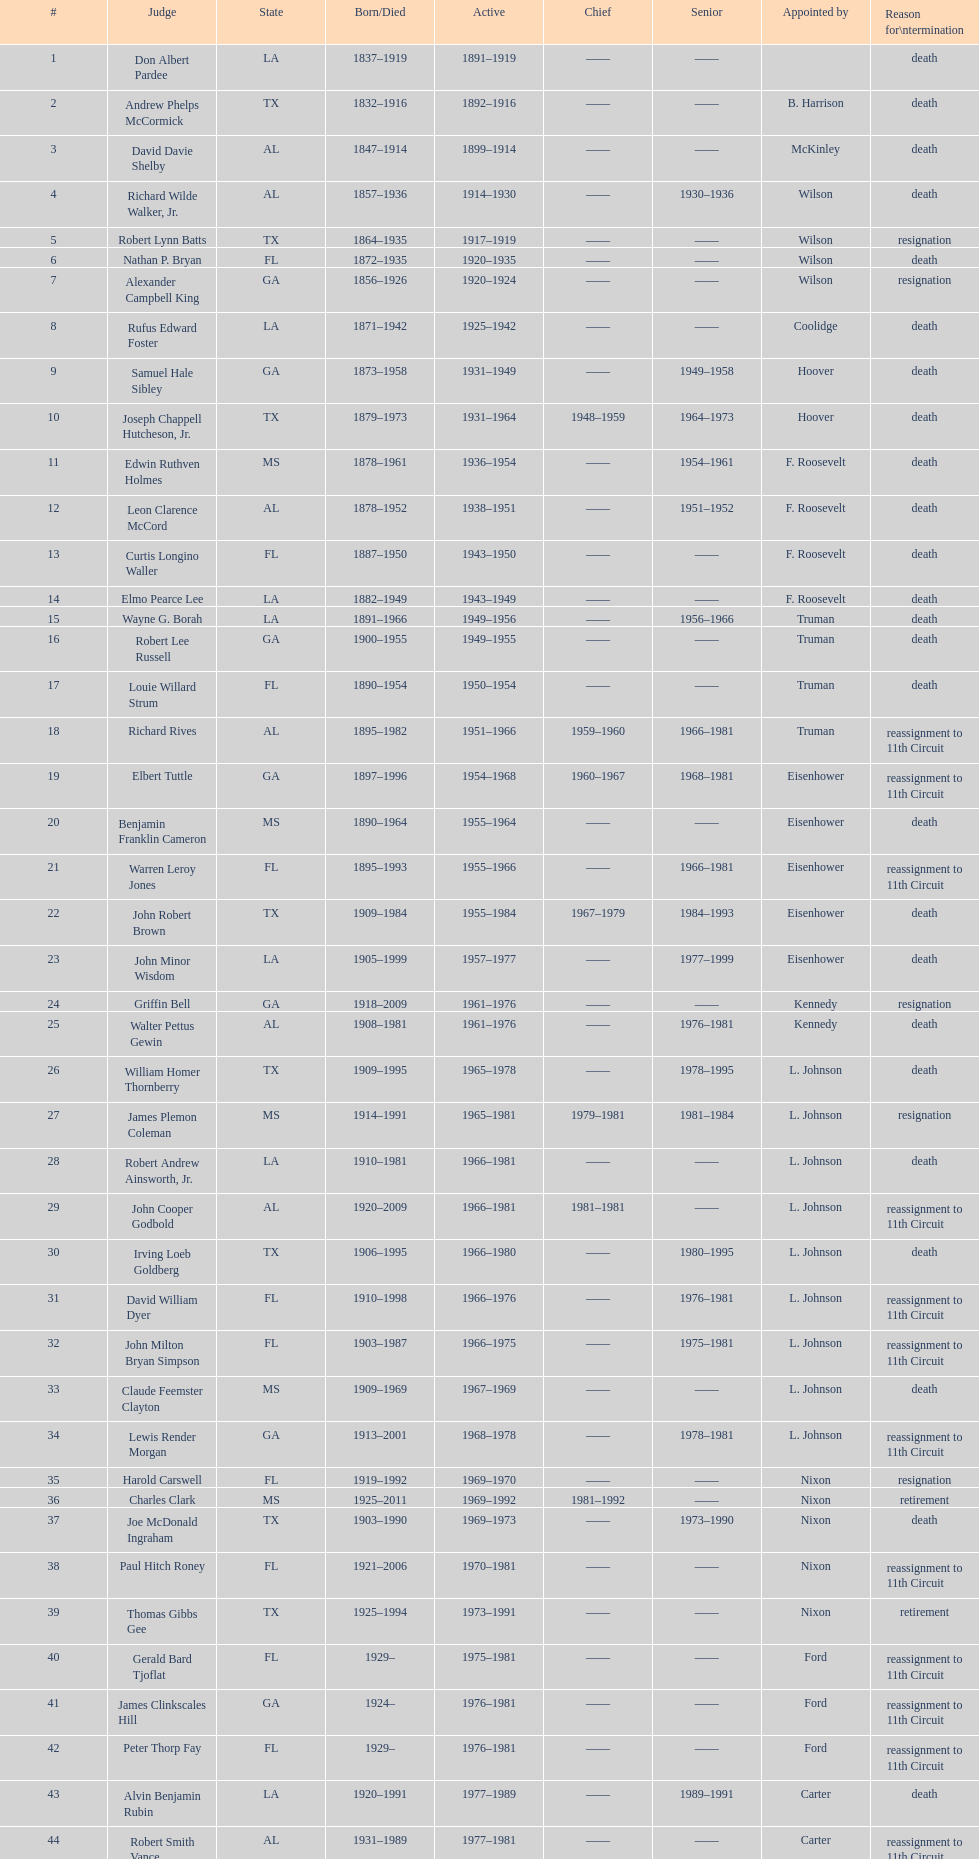Who was the next judge to resign after alexander campbell king? Griffin Bell. 